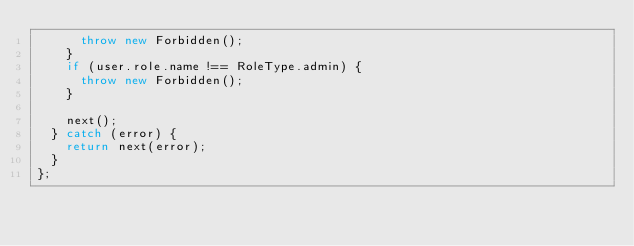Convert code to text. <code><loc_0><loc_0><loc_500><loc_500><_TypeScript_>      throw new Forbidden();
    }
    if (user.role.name !== RoleType.admin) {
      throw new Forbidden();
    }

    next();
  } catch (error) {
    return next(error);
  }
};
</code> 